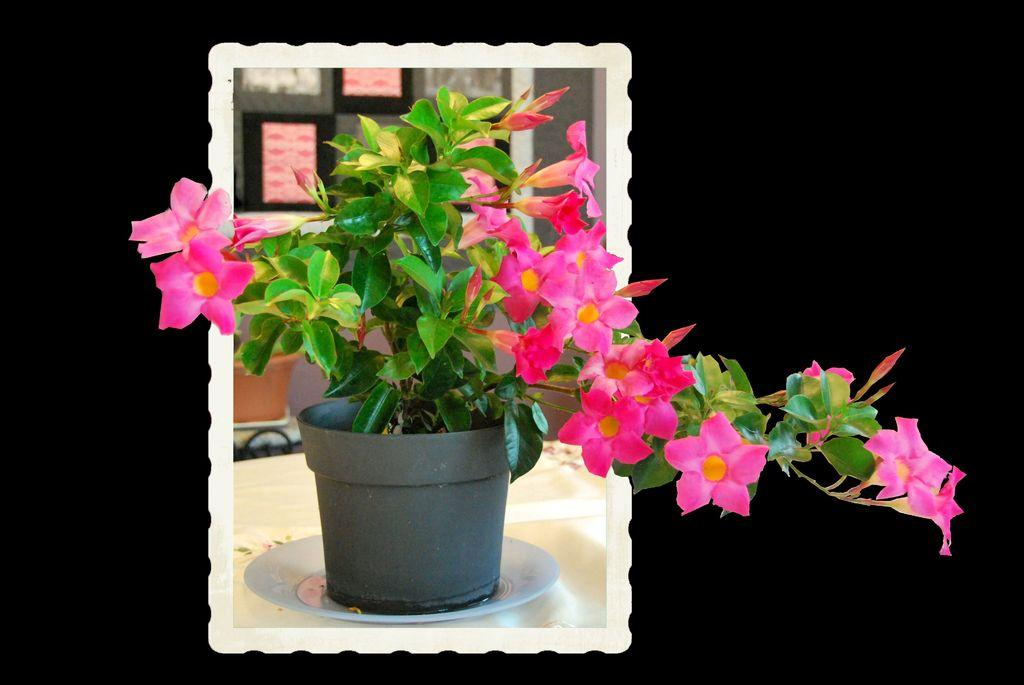What type of image is being described? The image is an edited picture. What can be seen on the table in the image? There is a potted plant with flowers on a table. What is visible in the background of the image? There is a pot and frames on the wall in the background. How many corks are visible in the image? There are no corks present in the image. What type of muscle is being flexed by the person in the image? There is no person in the image, so it is not possible to determine which muscle might be flexed. 